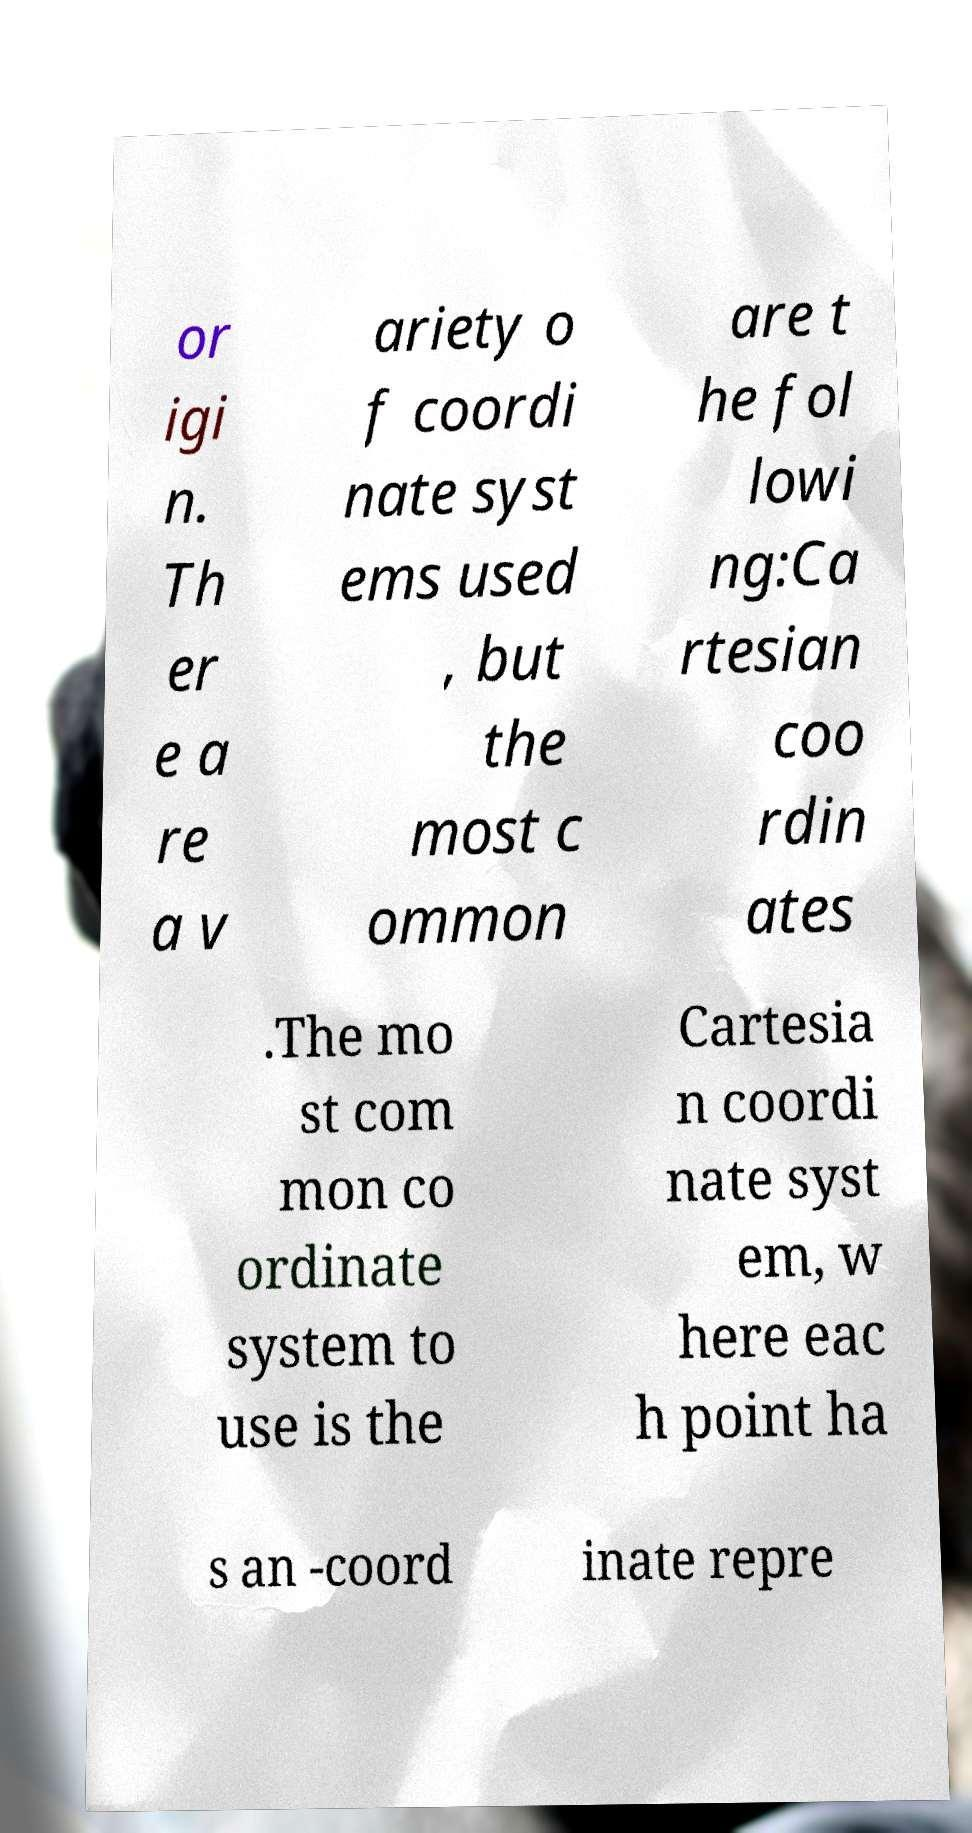Could you assist in decoding the text presented in this image and type it out clearly? or igi n. Th er e a re a v ariety o f coordi nate syst ems used , but the most c ommon are t he fol lowi ng:Ca rtesian coo rdin ates .The mo st com mon co ordinate system to use is the Cartesia n coordi nate syst em, w here eac h point ha s an -coord inate repre 